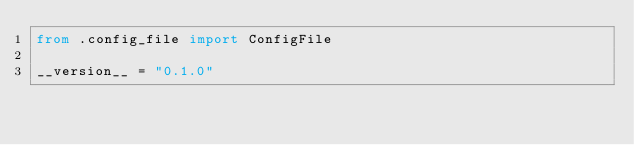<code> <loc_0><loc_0><loc_500><loc_500><_Python_>from .config_file import ConfigFile

__version__ = "0.1.0"
</code> 